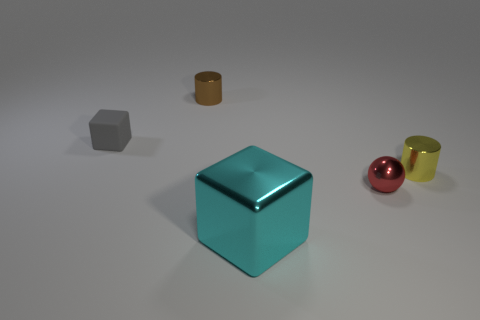Add 4 yellow shiny objects. How many objects exist? 9 Subtract all cubes. How many objects are left? 3 Add 5 cyan shiny blocks. How many cyan shiny blocks exist? 6 Subtract 0 purple spheres. How many objects are left? 5 Subtract all large cyan cubes. Subtract all tiny things. How many objects are left? 0 Add 2 tiny red metal balls. How many tiny red metal balls are left? 3 